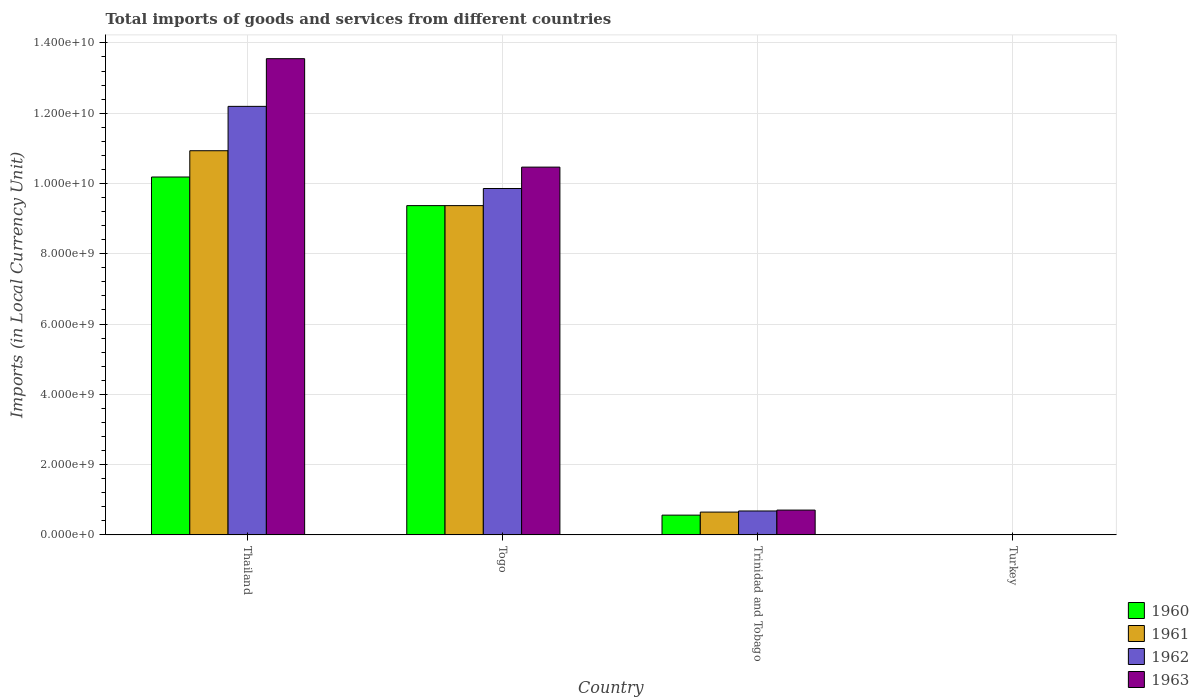What is the label of the 3rd group of bars from the left?
Keep it short and to the point. Trinidad and Tobago. In how many cases, is the number of bars for a given country not equal to the number of legend labels?
Offer a very short reply. 0. What is the Amount of goods and services imports in 1962 in Trinidad and Tobago?
Offer a terse response. 6.81e+08. Across all countries, what is the maximum Amount of goods and services imports in 1962?
Your response must be concise. 1.22e+1. Across all countries, what is the minimum Amount of goods and services imports in 1963?
Ensure brevity in your answer.  6500. In which country was the Amount of goods and services imports in 1961 maximum?
Offer a very short reply. Thailand. In which country was the Amount of goods and services imports in 1960 minimum?
Your response must be concise. Turkey. What is the total Amount of goods and services imports in 1960 in the graph?
Provide a succinct answer. 2.01e+1. What is the difference between the Amount of goods and services imports in 1960 in Togo and that in Turkey?
Your response must be concise. 9.37e+09. What is the difference between the Amount of goods and services imports in 1960 in Togo and the Amount of goods and services imports in 1963 in Turkey?
Your answer should be very brief. 9.37e+09. What is the average Amount of goods and services imports in 1960 per country?
Provide a short and direct response. 5.03e+09. What is the difference between the Amount of goods and services imports of/in 1963 and Amount of goods and services imports of/in 1960 in Thailand?
Offer a terse response. 3.37e+09. What is the ratio of the Amount of goods and services imports in 1961 in Togo to that in Trinidad and Tobago?
Ensure brevity in your answer.  14.44. Is the Amount of goods and services imports in 1961 in Trinidad and Tobago less than that in Turkey?
Provide a succinct answer. No. Is the difference between the Amount of goods and services imports in 1963 in Togo and Trinidad and Tobago greater than the difference between the Amount of goods and services imports in 1960 in Togo and Trinidad and Tobago?
Give a very brief answer. Yes. What is the difference between the highest and the second highest Amount of goods and services imports in 1962?
Give a very brief answer. 1.15e+1. What is the difference between the highest and the lowest Amount of goods and services imports in 1961?
Give a very brief answer. 1.09e+1. In how many countries, is the Amount of goods and services imports in 1961 greater than the average Amount of goods and services imports in 1961 taken over all countries?
Provide a succinct answer. 2. Is the sum of the Amount of goods and services imports in 1962 in Thailand and Trinidad and Tobago greater than the maximum Amount of goods and services imports in 1963 across all countries?
Provide a short and direct response. No. Is it the case that in every country, the sum of the Amount of goods and services imports in 1960 and Amount of goods and services imports in 1963 is greater than the sum of Amount of goods and services imports in 1961 and Amount of goods and services imports in 1962?
Give a very brief answer. No. What does the 2nd bar from the left in Trinidad and Tobago represents?
Offer a terse response. 1961. How many bars are there?
Provide a succinct answer. 16. Are all the bars in the graph horizontal?
Your response must be concise. No. Does the graph contain any zero values?
Offer a terse response. No. Does the graph contain grids?
Provide a succinct answer. Yes. How many legend labels are there?
Offer a terse response. 4. What is the title of the graph?
Your answer should be compact. Total imports of goods and services from different countries. What is the label or title of the Y-axis?
Give a very brief answer. Imports (in Local Currency Unit). What is the Imports (in Local Currency Unit) in 1960 in Thailand?
Make the answer very short. 1.02e+1. What is the Imports (in Local Currency Unit) of 1961 in Thailand?
Provide a succinct answer. 1.09e+1. What is the Imports (in Local Currency Unit) in 1962 in Thailand?
Your response must be concise. 1.22e+1. What is the Imports (in Local Currency Unit) of 1963 in Thailand?
Ensure brevity in your answer.  1.36e+1. What is the Imports (in Local Currency Unit) in 1960 in Togo?
Offer a very short reply. 9.37e+09. What is the Imports (in Local Currency Unit) in 1961 in Togo?
Ensure brevity in your answer.  9.37e+09. What is the Imports (in Local Currency Unit) of 1962 in Togo?
Provide a succinct answer. 9.86e+09. What is the Imports (in Local Currency Unit) of 1963 in Togo?
Offer a terse response. 1.05e+1. What is the Imports (in Local Currency Unit) in 1960 in Trinidad and Tobago?
Your response must be concise. 5.62e+08. What is the Imports (in Local Currency Unit) in 1961 in Trinidad and Tobago?
Offer a terse response. 6.49e+08. What is the Imports (in Local Currency Unit) in 1962 in Trinidad and Tobago?
Keep it short and to the point. 6.81e+08. What is the Imports (in Local Currency Unit) of 1963 in Trinidad and Tobago?
Your answer should be very brief. 7.06e+08. What is the Imports (in Local Currency Unit) in 1960 in Turkey?
Keep it short and to the point. 2500. What is the Imports (in Local Currency Unit) in 1961 in Turkey?
Your answer should be compact. 4900. What is the Imports (in Local Currency Unit) of 1962 in Turkey?
Provide a short and direct response. 6400. What is the Imports (in Local Currency Unit) of 1963 in Turkey?
Provide a succinct answer. 6500. Across all countries, what is the maximum Imports (in Local Currency Unit) in 1960?
Offer a terse response. 1.02e+1. Across all countries, what is the maximum Imports (in Local Currency Unit) of 1961?
Offer a terse response. 1.09e+1. Across all countries, what is the maximum Imports (in Local Currency Unit) of 1962?
Make the answer very short. 1.22e+1. Across all countries, what is the maximum Imports (in Local Currency Unit) in 1963?
Offer a terse response. 1.36e+1. Across all countries, what is the minimum Imports (in Local Currency Unit) of 1960?
Your response must be concise. 2500. Across all countries, what is the minimum Imports (in Local Currency Unit) of 1961?
Your response must be concise. 4900. Across all countries, what is the minimum Imports (in Local Currency Unit) of 1962?
Your response must be concise. 6400. Across all countries, what is the minimum Imports (in Local Currency Unit) of 1963?
Provide a short and direct response. 6500. What is the total Imports (in Local Currency Unit) of 1960 in the graph?
Give a very brief answer. 2.01e+1. What is the total Imports (in Local Currency Unit) of 1961 in the graph?
Your response must be concise. 2.10e+1. What is the total Imports (in Local Currency Unit) of 1962 in the graph?
Your answer should be very brief. 2.27e+1. What is the total Imports (in Local Currency Unit) of 1963 in the graph?
Offer a very short reply. 2.47e+1. What is the difference between the Imports (in Local Currency Unit) of 1960 in Thailand and that in Togo?
Keep it short and to the point. 8.14e+08. What is the difference between the Imports (in Local Currency Unit) of 1961 in Thailand and that in Togo?
Provide a short and direct response. 1.56e+09. What is the difference between the Imports (in Local Currency Unit) in 1962 in Thailand and that in Togo?
Your answer should be compact. 2.34e+09. What is the difference between the Imports (in Local Currency Unit) in 1963 in Thailand and that in Togo?
Make the answer very short. 3.09e+09. What is the difference between the Imports (in Local Currency Unit) of 1960 in Thailand and that in Trinidad and Tobago?
Give a very brief answer. 9.62e+09. What is the difference between the Imports (in Local Currency Unit) of 1961 in Thailand and that in Trinidad and Tobago?
Provide a succinct answer. 1.03e+1. What is the difference between the Imports (in Local Currency Unit) in 1962 in Thailand and that in Trinidad and Tobago?
Your answer should be very brief. 1.15e+1. What is the difference between the Imports (in Local Currency Unit) of 1963 in Thailand and that in Trinidad and Tobago?
Give a very brief answer. 1.28e+1. What is the difference between the Imports (in Local Currency Unit) in 1960 in Thailand and that in Turkey?
Offer a very short reply. 1.02e+1. What is the difference between the Imports (in Local Currency Unit) of 1961 in Thailand and that in Turkey?
Offer a terse response. 1.09e+1. What is the difference between the Imports (in Local Currency Unit) of 1962 in Thailand and that in Turkey?
Provide a short and direct response. 1.22e+1. What is the difference between the Imports (in Local Currency Unit) in 1963 in Thailand and that in Turkey?
Your response must be concise. 1.36e+1. What is the difference between the Imports (in Local Currency Unit) of 1960 in Togo and that in Trinidad and Tobago?
Keep it short and to the point. 8.81e+09. What is the difference between the Imports (in Local Currency Unit) in 1961 in Togo and that in Trinidad and Tobago?
Ensure brevity in your answer.  8.72e+09. What is the difference between the Imports (in Local Currency Unit) of 1962 in Togo and that in Trinidad and Tobago?
Ensure brevity in your answer.  9.18e+09. What is the difference between the Imports (in Local Currency Unit) in 1963 in Togo and that in Trinidad and Tobago?
Your answer should be very brief. 9.76e+09. What is the difference between the Imports (in Local Currency Unit) of 1960 in Togo and that in Turkey?
Offer a very short reply. 9.37e+09. What is the difference between the Imports (in Local Currency Unit) in 1961 in Togo and that in Turkey?
Keep it short and to the point. 9.37e+09. What is the difference between the Imports (in Local Currency Unit) of 1962 in Togo and that in Turkey?
Ensure brevity in your answer.  9.86e+09. What is the difference between the Imports (in Local Currency Unit) in 1963 in Togo and that in Turkey?
Ensure brevity in your answer.  1.05e+1. What is the difference between the Imports (in Local Currency Unit) in 1960 in Trinidad and Tobago and that in Turkey?
Offer a very short reply. 5.62e+08. What is the difference between the Imports (in Local Currency Unit) in 1961 in Trinidad and Tobago and that in Turkey?
Ensure brevity in your answer.  6.49e+08. What is the difference between the Imports (in Local Currency Unit) in 1962 in Trinidad and Tobago and that in Turkey?
Your response must be concise. 6.81e+08. What is the difference between the Imports (in Local Currency Unit) in 1963 in Trinidad and Tobago and that in Turkey?
Your response must be concise. 7.06e+08. What is the difference between the Imports (in Local Currency Unit) in 1960 in Thailand and the Imports (in Local Currency Unit) in 1961 in Togo?
Your answer should be compact. 8.14e+08. What is the difference between the Imports (in Local Currency Unit) of 1960 in Thailand and the Imports (in Local Currency Unit) of 1962 in Togo?
Offer a very short reply. 3.27e+08. What is the difference between the Imports (in Local Currency Unit) in 1960 in Thailand and the Imports (in Local Currency Unit) in 1963 in Togo?
Provide a succinct answer. -2.81e+08. What is the difference between the Imports (in Local Currency Unit) of 1961 in Thailand and the Imports (in Local Currency Unit) of 1962 in Togo?
Offer a terse response. 1.08e+09. What is the difference between the Imports (in Local Currency Unit) of 1961 in Thailand and the Imports (in Local Currency Unit) of 1963 in Togo?
Offer a very short reply. 4.67e+08. What is the difference between the Imports (in Local Currency Unit) of 1962 in Thailand and the Imports (in Local Currency Unit) of 1963 in Togo?
Offer a very short reply. 1.73e+09. What is the difference between the Imports (in Local Currency Unit) in 1960 in Thailand and the Imports (in Local Currency Unit) in 1961 in Trinidad and Tobago?
Offer a terse response. 9.54e+09. What is the difference between the Imports (in Local Currency Unit) in 1960 in Thailand and the Imports (in Local Currency Unit) in 1962 in Trinidad and Tobago?
Provide a short and direct response. 9.50e+09. What is the difference between the Imports (in Local Currency Unit) in 1960 in Thailand and the Imports (in Local Currency Unit) in 1963 in Trinidad and Tobago?
Offer a terse response. 9.48e+09. What is the difference between the Imports (in Local Currency Unit) in 1961 in Thailand and the Imports (in Local Currency Unit) in 1962 in Trinidad and Tobago?
Your answer should be compact. 1.03e+1. What is the difference between the Imports (in Local Currency Unit) in 1961 in Thailand and the Imports (in Local Currency Unit) in 1963 in Trinidad and Tobago?
Your answer should be very brief. 1.02e+1. What is the difference between the Imports (in Local Currency Unit) of 1962 in Thailand and the Imports (in Local Currency Unit) of 1963 in Trinidad and Tobago?
Your answer should be compact. 1.15e+1. What is the difference between the Imports (in Local Currency Unit) of 1960 in Thailand and the Imports (in Local Currency Unit) of 1961 in Turkey?
Keep it short and to the point. 1.02e+1. What is the difference between the Imports (in Local Currency Unit) of 1960 in Thailand and the Imports (in Local Currency Unit) of 1962 in Turkey?
Make the answer very short. 1.02e+1. What is the difference between the Imports (in Local Currency Unit) of 1960 in Thailand and the Imports (in Local Currency Unit) of 1963 in Turkey?
Make the answer very short. 1.02e+1. What is the difference between the Imports (in Local Currency Unit) in 1961 in Thailand and the Imports (in Local Currency Unit) in 1962 in Turkey?
Your response must be concise. 1.09e+1. What is the difference between the Imports (in Local Currency Unit) of 1961 in Thailand and the Imports (in Local Currency Unit) of 1963 in Turkey?
Give a very brief answer. 1.09e+1. What is the difference between the Imports (in Local Currency Unit) of 1962 in Thailand and the Imports (in Local Currency Unit) of 1963 in Turkey?
Your answer should be compact. 1.22e+1. What is the difference between the Imports (in Local Currency Unit) in 1960 in Togo and the Imports (in Local Currency Unit) in 1961 in Trinidad and Tobago?
Give a very brief answer. 8.72e+09. What is the difference between the Imports (in Local Currency Unit) of 1960 in Togo and the Imports (in Local Currency Unit) of 1962 in Trinidad and Tobago?
Offer a terse response. 8.69e+09. What is the difference between the Imports (in Local Currency Unit) of 1960 in Togo and the Imports (in Local Currency Unit) of 1963 in Trinidad and Tobago?
Your response must be concise. 8.66e+09. What is the difference between the Imports (in Local Currency Unit) of 1961 in Togo and the Imports (in Local Currency Unit) of 1962 in Trinidad and Tobago?
Offer a very short reply. 8.69e+09. What is the difference between the Imports (in Local Currency Unit) of 1961 in Togo and the Imports (in Local Currency Unit) of 1963 in Trinidad and Tobago?
Your response must be concise. 8.66e+09. What is the difference between the Imports (in Local Currency Unit) of 1962 in Togo and the Imports (in Local Currency Unit) of 1963 in Trinidad and Tobago?
Ensure brevity in your answer.  9.15e+09. What is the difference between the Imports (in Local Currency Unit) in 1960 in Togo and the Imports (in Local Currency Unit) in 1961 in Turkey?
Your response must be concise. 9.37e+09. What is the difference between the Imports (in Local Currency Unit) in 1960 in Togo and the Imports (in Local Currency Unit) in 1962 in Turkey?
Your response must be concise. 9.37e+09. What is the difference between the Imports (in Local Currency Unit) of 1960 in Togo and the Imports (in Local Currency Unit) of 1963 in Turkey?
Keep it short and to the point. 9.37e+09. What is the difference between the Imports (in Local Currency Unit) in 1961 in Togo and the Imports (in Local Currency Unit) in 1962 in Turkey?
Ensure brevity in your answer.  9.37e+09. What is the difference between the Imports (in Local Currency Unit) of 1961 in Togo and the Imports (in Local Currency Unit) of 1963 in Turkey?
Give a very brief answer. 9.37e+09. What is the difference between the Imports (in Local Currency Unit) in 1962 in Togo and the Imports (in Local Currency Unit) in 1963 in Turkey?
Provide a succinct answer. 9.86e+09. What is the difference between the Imports (in Local Currency Unit) in 1960 in Trinidad and Tobago and the Imports (in Local Currency Unit) in 1961 in Turkey?
Keep it short and to the point. 5.62e+08. What is the difference between the Imports (in Local Currency Unit) of 1960 in Trinidad and Tobago and the Imports (in Local Currency Unit) of 1962 in Turkey?
Give a very brief answer. 5.62e+08. What is the difference between the Imports (in Local Currency Unit) of 1960 in Trinidad and Tobago and the Imports (in Local Currency Unit) of 1963 in Turkey?
Ensure brevity in your answer.  5.62e+08. What is the difference between the Imports (in Local Currency Unit) of 1961 in Trinidad and Tobago and the Imports (in Local Currency Unit) of 1962 in Turkey?
Your answer should be compact. 6.49e+08. What is the difference between the Imports (in Local Currency Unit) in 1961 in Trinidad and Tobago and the Imports (in Local Currency Unit) in 1963 in Turkey?
Ensure brevity in your answer.  6.49e+08. What is the difference between the Imports (in Local Currency Unit) in 1962 in Trinidad and Tobago and the Imports (in Local Currency Unit) in 1963 in Turkey?
Offer a very short reply. 6.81e+08. What is the average Imports (in Local Currency Unit) in 1960 per country?
Offer a very short reply. 5.03e+09. What is the average Imports (in Local Currency Unit) of 1961 per country?
Keep it short and to the point. 5.24e+09. What is the average Imports (in Local Currency Unit) of 1962 per country?
Your answer should be compact. 5.68e+09. What is the average Imports (in Local Currency Unit) of 1963 per country?
Provide a succinct answer. 6.18e+09. What is the difference between the Imports (in Local Currency Unit) of 1960 and Imports (in Local Currency Unit) of 1961 in Thailand?
Offer a very short reply. -7.48e+08. What is the difference between the Imports (in Local Currency Unit) of 1960 and Imports (in Local Currency Unit) of 1962 in Thailand?
Make the answer very short. -2.01e+09. What is the difference between the Imports (in Local Currency Unit) in 1960 and Imports (in Local Currency Unit) in 1963 in Thailand?
Offer a terse response. -3.37e+09. What is the difference between the Imports (in Local Currency Unit) of 1961 and Imports (in Local Currency Unit) of 1962 in Thailand?
Your response must be concise. -1.26e+09. What is the difference between the Imports (in Local Currency Unit) of 1961 and Imports (in Local Currency Unit) of 1963 in Thailand?
Your answer should be compact. -2.62e+09. What is the difference between the Imports (in Local Currency Unit) in 1962 and Imports (in Local Currency Unit) in 1963 in Thailand?
Your response must be concise. -1.36e+09. What is the difference between the Imports (in Local Currency Unit) of 1960 and Imports (in Local Currency Unit) of 1961 in Togo?
Your answer should be compact. 0. What is the difference between the Imports (in Local Currency Unit) in 1960 and Imports (in Local Currency Unit) in 1962 in Togo?
Make the answer very short. -4.87e+08. What is the difference between the Imports (in Local Currency Unit) in 1960 and Imports (in Local Currency Unit) in 1963 in Togo?
Offer a very short reply. -1.10e+09. What is the difference between the Imports (in Local Currency Unit) of 1961 and Imports (in Local Currency Unit) of 1962 in Togo?
Offer a terse response. -4.87e+08. What is the difference between the Imports (in Local Currency Unit) of 1961 and Imports (in Local Currency Unit) of 1963 in Togo?
Provide a short and direct response. -1.10e+09. What is the difference between the Imports (in Local Currency Unit) in 1962 and Imports (in Local Currency Unit) in 1963 in Togo?
Keep it short and to the point. -6.08e+08. What is the difference between the Imports (in Local Currency Unit) of 1960 and Imports (in Local Currency Unit) of 1961 in Trinidad and Tobago?
Give a very brief answer. -8.67e+07. What is the difference between the Imports (in Local Currency Unit) of 1960 and Imports (in Local Currency Unit) of 1962 in Trinidad and Tobago?
Offer a terse response. -1.18e+08. What is the difference between the Imports (in Local Currency Unit) in 1960 and Imports (in Local Currency Unit) in 1963 in Trinidad and Tobago?
Ensure brevity in your answer.  -1.44e+08. What is the difference between the Imports (in Local Currency Unit) in 1961 and Imports (in Local Currency Unit) in 1962 in Trinidad and Tobago?
Ensure brevity in your answer.  -3.17e+07. What is the difference between the Imports (in Local Currency Unit) in 1961 and Imports (in Local Currency Unit) in 1963 in Trinidad and Tobago?
Offer a very short reply. -5.69e+07. What is the difference between the Imports (in Local Currency Unit) of 1962 and Imports (in Local Currency Unit) of 1963 in Trinidad and Tobago?
Offer a terse response. -2.52e+07. What is the difference between the Imports (in Local Currency Unit) of 1960 and Imports (in Local Currency Unit) of 1961 in Turkey?
Give a very brief answer. -2400. What is the difference between the Imports (in Local Currency Unit) of 1960 and Imports (in Local Currency Unit) of 1962 in Turkey?
Make the answer very short. -3900. What is the difference between the Imports (in Local Currency Unit) in 1960 and Imports (in Local Currency Unit) in 1963 in Turkey?
Ensure brevity in your answer.  -4000. What is the difference between the Imports (in Local Currency Unit) of 1961 and Imports (in Local Currency Unit) of 1962 in Turkey?
Your answer should be compact. -1500. What is the difference between the Imports (in Local Currency Unit) of 1961 and Imports (in Local Currency Unit) of 1963 in Turkey?
Keep it short and to the point. -1600. What is the difference between the Imports (in Local Currency Unit) in 1962 and Imports (in Local Currency Unit) in 1963 in Turkey?
Your answer should be compact. -100. What is the ratio of the Imports (in Local Currency Unit) of 1960 in Thailand to that in Togo?
Make the answer very short. 1.09. What is the ratio of the Imports (in Local Currency Unit) of 1961 in Thailand to that in Togo?
Provide a succinct answer. 1.17. What is the ratio of the Imports (in Local Currency Unit) of 1962 in Thailand to that in Togo?
Ensure brevity in your answer.  1.24. What is the ratio of the Imports (in Local Currency Unit) of 1963 in Thailand to that in Togo?
Your response must be concise. 1.29. What is the ratio of the Imports (in Local Currency Unit) of 1960 in Thailand to that in Trinidad and Tobago?
Ensure brevity in your answer.  18.11. What is the ratio of the Imports (in Local Currency Unit) of 1961 in Thailand to that in Trinidad and Tobago?
Keep it short and to the point. 16.85. What is the ratio of the Imports (in Local Currency Unit) in 1962 in Thailand to that in Trinidad and Tobago?
Your response must be concise. 17.92. What is the ratio of the Imports (in Local Currency Unit) in 1963 in Thailand to that in Trinidad and Tobago?
Give a very brief answer. 19.2. What is the ratio of the Imports (in Local Currency Unit) in 1960 in Thailand to that in Turkey?
Make the answer very short. 4.07e+06. What is the ratio of the Imports (in Local Currency Unit) in 1961 in Thailand to that in Turkey?
Provide a short and direct response. 2.23e+06. What is the ratio of the Imports (in Local Currency Unit) of 1962 in Thailand to that in Turkey?
Offer a terse response. 1.91e+06. What is the ratio of the Imports (in Local Currency Unit) in 1963 in Thailand to that in Turkey?
Your response must be concise. 2.08e+06. What is the ratio of the Imports (in Local Currency Unit) of 1960 in Togo to that in Trinidad and Tobago?
Offer a very short reply. 16.67. What is the ratio of the Imports (in Local Currency Unit) in 1961 in Togo to that in Trinidad and Tobago?
Your answer should be very brief. 14.44. What is the ratio of the Imports (in Local Currency Unit) of 1962 in Togo to that in Trinidad and Tobago?
Give a very brief answer. 14.48. What is the ratio of the Imports (in Local Currency Unit) of 1963 in Togo to that in Trinidad and Tobago?
Your answer should be very brief. 14.83. What is the ratio of the Imports (in Local Currency Unit) of 1960 in Togo to that in Turkey?
Give a very brief answer. 3.75e+06. What is the ratio of the Imports (in Local Currency Unit) of 1961 in Togo to that in Turkey?
Make the answer very short. 1.91e+06. What is the ratio of the Imports (in Local Currency Unit) in 1962 in Togo to that in Turkey?
Provide a short and direct response. 1.54e+06. What is the ratio of the Imports (in Local Currency Unit) in 1963 in Togo to that in Turkey?
Ensure brevity in your answer.  1.61e+06. What is the ratio of the Imports (in Local Currency Unit) in 1960 in Trinidad and Tobago to that in Turkey?
Make the answer very short. 2.25e+05. What is the ratio of the Imports (in Local Currency Unit) in 1961 in Trinidad and Tobago to that in Turkey?
Give a very brief answer. 1.32e+05. What is the ratio of the Imports (in Local Currency Unit) in 1962 in Trinidad and Tobago to that in Turkey?
Provide a short and direct response. 1.06e+05. What is the ratio of the Imports (in Local Currency Unit) in 1963 in Trinidad and Tobago to that in Turkey?
Make the answer very short. 1.09e+05. What is the difference between the highest and the second highest Imports (in Local Currency Unit) of 1960?
Keep it short and to the point. 8.14e+08. What is the difference between the highest and the second highest Imports (in Local Currency Unit) of 1961?
Give a very brief answer. 1.56e+09. What is the difference between the highest and the second highest Imports (in Local Currency Unit) in 1962?
Your answer should be very brief. 2.34e+09. What is the difference between the highest and the second highest Imports (in Local Currency Unit) in 1963?
Make the answer very short. 3.09e+09. What is the difference between the highest and the lowest Imports (in Local Currency Unit) in 1960?
Your response must be concise. 1.02e+1. What is the difference between the highest and the lowest Imports (in Local Currency Unit) of 1961?
Give a very brief answer. 1.09e+1. What is the difference between the highest and the lowest Imports (in Local Currency Unit) in 1962?
Your answer should be compact. 1.22e+1. What is the difference between the highest and the lowest Imports (in Local Currency Unit) in 1963?
Offer a very short reply. 1.36e+1. 